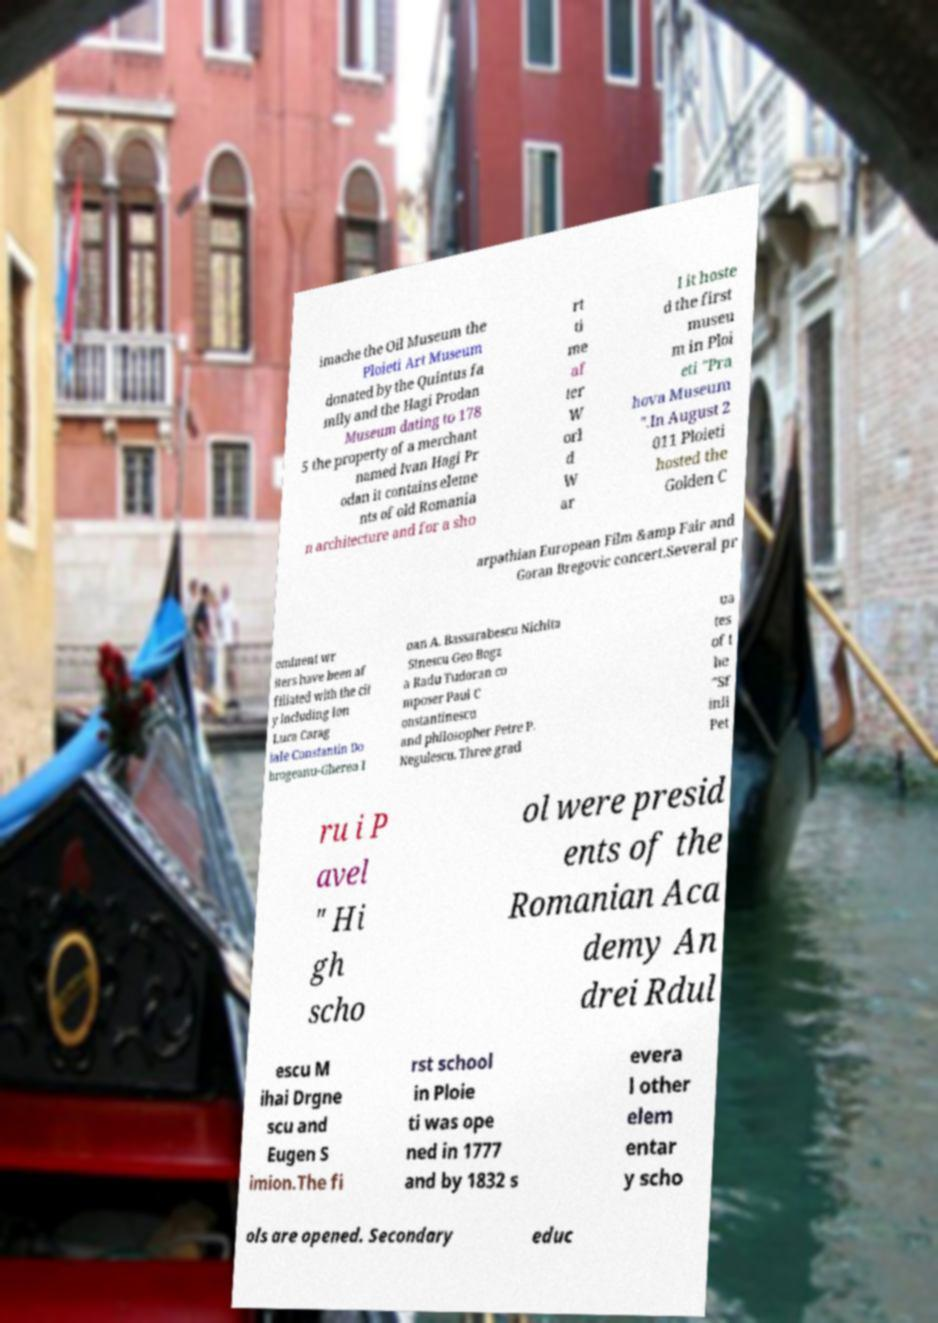Could you assist in decoding the text presented in this image and type it out clearly? imache the Oil Museum the Ploieti Art Museum donated by the Quintus fa mily and the Hagi Prodan Museum dating to 178 5 the property of a merchant named Ivan Hagi Pr odan it contains eleme nts of old Romania n architecture and for a sho rt ti me af ter W orl d W ar I it hoste d the first museu m in Ploi eti "Pra hova Museum ".In August 2 011 Ploieti hosted the Golden C arpathian European Film &amp Fair and Goran Bregovic concert.Several pr ominent wr iters have been af filiated with the cit y including Ion Luca Carag iale Constantin Do brogeanu-Gherea I oan A. Bassarabescu Nichita Stnescu Geo Bogz a Radu Tudoran co mposer Paul C onstantinescu and philosopher Petre P. Negulescu. Three grad ua tes of t he "Sf inii Pet ru i P avel " Hi gh scho ol were presid ents of the Romanian Aca demy An drei Rdul escu M ihai Drgne scu and Eugen S imion.The fi rst school in Ploie ti was ope ned in 1777 and by 1832 s evera l other elem entar y scho ols are opened. Secondary educ 